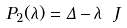<formula> <loc_0><loc_0><loc_500><loc_500>P _ { 2 } ( \lambda ) = \Delta - \lambda \ J</formula> 